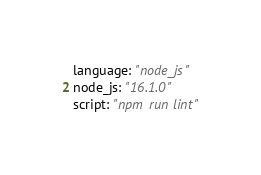Convert code to text. <code><loc_0><loc_0><loc_500><loc_500><_YAML_>language: "node_js"
node_js: "16.1.0"
script: "npm run lint"
</code> 